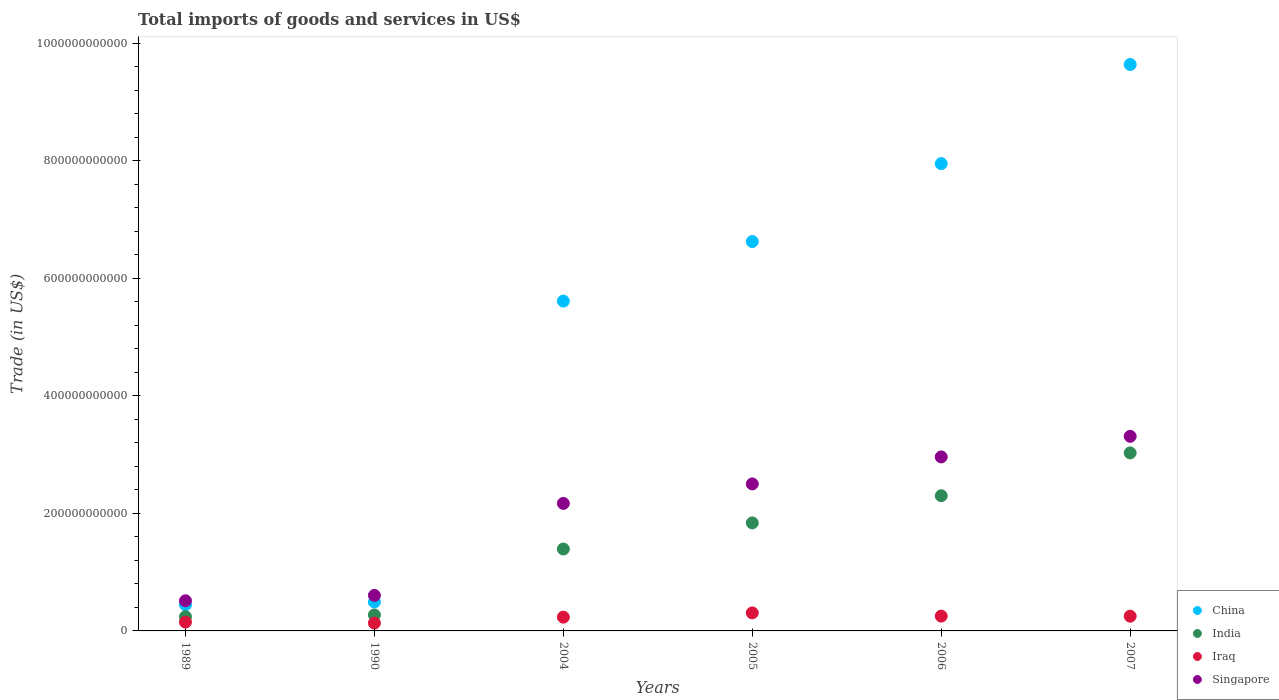How many different coloured dotlines are there?
Make the answer very short. 4. Is the number of dotlines equal to the number of legend labels?
Your answer should be very brief. Yes. What is the total imports of goods and services in Iraq in 1989?
Provide a succinct answer. 1.50e+1. Across all years, what is the maximum total imports of goods and services in Singapore?
Your answer should be very brief. 3.31e+11. Across all years, what is the minimum total imports of goods and services in Iraq?
Your answer should be very brief. 1.34e+1. In which year was the total imports of goods and services in China maximum?
Give a very brief answer. 2007. In which year was the total imports of goods and services in Singapore minimum?
Give a very brief answer. 1989. What is the total total imports of goods and services in Singapore in the graph?
Ensure brevity in your answer.  1.21e+12. What is the difference between the total imports of goods and services in India in 2004 and that in 2006?
Your answer should be very brief. -9.06e+1. What is the difference between the total imports of goods and services in Iraq in 2006 and the total imports of goods and services in Singapore in 1990?
Give a very brief answer. -3.53e+1. What is the average total imports of goods and services in Singapore per year?
Ensure brevity in your answer.  2.01e+11. In the year 2005, what is the difference between the total imports of goods and services in India and total imports of goods and services in China?
Your answer should be very brief. -4.79e+11. What is the ratio of the total imports of goods and services in Singapore in 1989 to that in 2005?
Give a very brief answer. 0.21. Is the total imports of goods and services in Singapore in 1990 less than that in 2006?
Make the answer very short. Yes. Is the difference between the total imports of goods and services in India in 1990 and 2005 greater than the difference between the total imports of goods and services in China in 1990 and 2005?
Give a very brief answer. Yes. What is the difference between the highest and the second highest total imports of goods and services in China?
Your answer should be compact. 1.69e+11. What is the difference between the highest and the lowest total imports of goods and services in China?
Your answer should be very brief. 9.19e+11. Does the total imports of goods and services in Iraq monotonically increase over the years?
Offer a very short reply. No. How many dotlines are there?
Your answer should be compact. 4. How many years are there in the graph?
Offer a very short reply. 6. What is the difference between two consecutive major ticks on the Y-axis?
Ensure brevity in your answer.  2.00e+11. Are the values on the major ticks of Y-axis written in scientific E-notation?
Make the answer very short. No. How many legend labels are there?
Offer a very short reply. 4. How are the legend labels stacked?
Give a very brief answer. Vertical. What is the title of the graph?
Make the answer very short. Total imports of goods and services in US$. What is the label or title of the Y-axis?
Your response must be concise. Trade (in US$). What is the Trade (in US$) in China in 1989?
Give a very brief answer. 4.45e+1. What is the Trade (in US$) in India in 1989?
Make the answer very short. 2.41e+1. What is the Trade (in US$) in Iraq in 1989?
Offer a terse response. 1.50e+1. What is the Trade (in US$) of Singapore in 1989?
Give a very brief answer. 5.13e+1. What is the Trade (in US$) of China in 1990?
Your answer should be compact. 4.92e+1. What is the Trade (in US$) of India in 1990?
Ensure brevity in your answer.  2.71e+1. What is the Trade (in US$) in Iraq in 1990?
Provide a succinct answer. 1.34e+1. What is the Trade (in US$) of Singapore in 1990?
Make the answer very short. 6.04e+1. What is the Trade (in US$) of China in 2004?
Make the answer very short. 5.61e+11. What is the Trade (in US$) in India in 2004?
Give a very brief answer. 1.39e+11. What is the Trade (in US$) in Iraq in 2004?
Make the answer very short. 2.34e+1. What is the Trade (in US$) in Singapore in 2004?
Give a very brief answer. 2.17e+11. What is the Trade (in US$) of China in 2005?
Give a very brief answer. 6.62e+11. What is the Trade (in US$) of India in 2005?
Your answer should be very brief. 1.84e+11. What is the Trade (in US$) of Iraq in 2005?
Offer a very short reply. 3.07e+1. What is the Trade (in US$) of Singapore in 2005?
Your answer should be compact. 2.50e+11. What is the Trade (in US$) in China in 2006?
Ensure brevity in your answer.  7.95e+11. What is the Trade (in US$) of India in 2006?
Your answer should be very brief. 2.30e+11. What is the Trade (in US$) in Iraq in 2006?
Provide a succinct answer. 2.52e+1. What is the Trade (in US$) in Singapore in 2006?
Your answer should be compact. 2.96e+11. What is the Trade (in US$) in China in 2007?
Ensure brevity in your answer.  9.63e+11. What is the Trade (in US$) of India in 2007?
Give a very brief answer. 3.03e+11. What is the Trade (in US$) of Iraq in 2007?
Your response must be concise. 2.50e+1. What is the Trade (in US$) of Singapore in 2007?
Your response must be concise. 3.31e+11. Across all years, what is the maximum Trade (in US$) of China?
Ensure brevity in your answer.  9.63e+11. Across all years, what is the maximum Trade (in US$) in India?
Provide a succinct answer. 3.03e+11. Across all years, what is the maximum Trade (in US$) of Iraq?
Ensure brevity in your answer.  3.07e+1. Across all years, what is the maximum Trade (in US$) in Singapore?
Provide a succinct answer. 3.31e+11. Across all years, what is the minimum Trade (in US$) of China?
Offer a very short reply. 4.45e+1. Across all years, what is the minimum Trade (in US$) in India?
Provide a short and direct response. 2.41e+1. Across all years, what is the minimum Trade (in US$) in Iraq?
Your response must be concise. 1.34e+1. Across all years, what is the minimum Trade (in US$) of Singapore?
Make the answer very short. 5.13e+1. What is the total Trade (in US$) of China in the graph?
Provide a short and direct response. 3.08e+12. What is the total Trade (in US$) of India in the graph?
Ensure brevity in your answer.  9.07e+11. What is the total Trade (in US$) of Iraq in the graph?
Provide a short and direct response. 1.33e+11. What is the total Trade (in US$) of Singapore in the graph?
Give a very brief answer. 1.21e+12. What is the difference between the Trade (in US$) of China in 1989 and that in 1990?
Keep it short and to the point. -4.69e+09. What is the difference between the Trade (in US$) of India in 1989 and that in 1990?
Provide a short and direct response. -3.00e+09. What is the difference between the Trade (in US$) in Iraq in 1989 and that in 1990?
Offer a terse response. 1.65e+09. What is the difference between the Trade (in US$) of Singapore in 1989 and that in 1990?
Your response must be concise. -9.15e+09. What is the difference between the Trade (in US$) of China in 1989 and that in 2004?
Give a very brief answer. -5.17e+11. What is the difference between the Trade (in US$) in India in 1989 and that in 2004?
Offer a very short reply. -1.15e+11. What is the difference between the Trade (in US$) of Iraq in 1989 and that in 2004?
Your response must be concise. -8.41e+09. What is the difference between the Trade (in US$) of Singapore in 1989 and that in 2004?
Provide a short and direct response. -1.66e+11. What is the difference between the Trade (in US$) of China in 1989 and that in 2005?
Your answer should be very brief. -6.18e+11. What is the difference between the Trade (in US$) of India in 1989 and that in 2005?
Give a very brief answer. -1.60e+11. What is the difference between the Trade (in US$) of Iraq in 1989 and that in 2005?
Provide a succinct answer. -1.57e+1. What is the difference between the Trade (in US$) in Singapore in 1989 and that in 2005?
Give a very brief answer. -1.99e+11. What is the difference between the Trade (in US$) in China in 1989 and that in 2006?
Offer a very short reply. -7.50e+11. What is the difference between the Trade (in US$) of India in 1989 and that in 2006?
Keep it short and to the point. -2.06e+11. What is the difference between the Trade (in US$) in Iraq in 1989 and that in 2006?
Offer a very short reply. -1.01e+1. What is the difference between the Trade (in US$) in Singapore in 1989 and that in 2006?
Your response must be concise. -2.45e+11. What is the difference between the Trade (in US$) in China in 1989 and that in 2007?
Ensure brevity in your answer.  -9.19e+11. What is the difference between the Trade (in US$) of India in 1989 and that in 2007?
Offer a terse response. -2.79e+11. What is the difference between the Trade (in US$) of Iraq in 1989 and that in 2007?
Your answer should be compact. -1.00e+1. What is the difference between the Trade (in US$) of Singapore in 1989 and that in 2007?
Your response must be concise. -2.80e+11. What is the difference between the Trade (in US$) of China in 1990 and that in 2004?
Provide a succinct answer. -5.12e+11. What is the difference between the Trade (in US$) in India in 1990 and that in 2004?
Keep it short and to the point. -1.12e+11. What is the difference between the Trade (in US$) of Iraq in 1990 and that in 2004?
Offer a very short reply. -1.01e+1. What is the difference between the Trade (in US$) in Singapore in 1990 and that in 2004?
Provide a short and direct response. -1.56e+11. What is the difference between the Trade (in US$) of China in 1990 and that in 2005?
Your answer should be very brief. -6.13e+11. What is the difference between the Trade (in US$) of India in 1990 and that in 2005?
Ensure brevity in your answer.  -1.57e+11. What is the difference between the Trade (in US$) of Iraq in 1990 and that in 2005?
Provide a short and direct response. -1.73e+1. What is the difference between the Trade (in US$) in Singapore in 1990 and that in 2005?
Ensure brevity in your answer.  -1.90e+11. What is the difference between the Trade (in US$) in China in 1990 and that in 2006?
Your response must be concise. -7.46e+11. What is the difference between the Trade (in US$) of India in 1990 and that in 2006?
Your response must be concise. -2.03e+11. What is the difference between the Trade (in US$) of Iraq in 1990 and that in 2006?
Your answer should be compact. -1.18e+1. What is the difference between the Trade (in US$) in Singapore in 1990 and that in 2006?
Ensure brevity in your answer.  -2.36e+11. What is the difference between the Trade (in US$) of China in 1990 and that in 2007?
Make the answer very short. -9.14e+11. What is the difference between the Trade (in US$) in India in 1990 and that in 2007?
Make the answer very short. -2.76e+11. What is the difference between the Trade (in US$) in Iraq in 1990 and that in 2007?
Make the answer very short. -1.17e+1. What is the difference between the Trade (in US$) in Singapore in 1990 and that in 2007?
Ensure brevity in your answer.  -2.71e+11. What is the difference between the Trade (in US$) of China in 2004 and that in 2005?
Offer a very short reply. -1.01e+11. What is the difference between the Trade (in US$) in India in 2004 and that in 2005?
Provide a short and direct response. -4.44e+1. What is the difference between the Trade (in US$) of Iraq in 2004 and that in 2005?
Keep it short and to the point. -7.24e+09. What is the difference between the Trade (in US$) in Singapore in 2004 and that in 2005?
Ensure brevity in your answer.  -3.32e+1. What is the difference between the Trade (in US$) in China in 2004 and that in 2006?
Offer a very short reply. -2.34e+11. What is the difference between the Trade (in US$) of India in 2004 and that in 2006?
Your answer should be very brief. -9.06e+1. What is the difference between the Trade (in US$) in Iraq in 2004 and that in 2006?
Your answer should be compact. -1.73e+09. What is the difference between the Trade (in US$) in Singapore in 2004 and that in 2006?
Make the answer very short. -7.91e+1. What is the difference between the Trade (in US$) of China in 2004 and that in 2007?
Your answer should be compact. -4.02e+11. What is the difference between the Trade (in US$) of India in 2004 and that in 2007?
Ensure brevity in your answer.  -1.63e+11. What is the difference between the Trade (in US$) of Iraq in 2004 and that in 2007?
Offer a terse response. -1.62e+09. What is the difference between the Trade (in US$) of Singapore in 2004 and that in 2007?
Provide a short and direct response. -1.14e+11. What is the difference between the Trade (in US$) of China in 2005 and that in 2006?
Offer a terse response. -1.33e+11. What is the difference between the Trade (in US$) of India in 2005 and that in 2006?
Your response must be concise. -4.62e+1. What is the difference between the Trade (in US$) in Iraq in 2005 and that in 2006?
Ensure brevity in your answer.  5.51e+09. What is the difference between the Trade (in US$) in Singapore in 2005 and that in 2006?
Ensure brevity in your answer.  -4.59e+1. What is the difference between the Trade (in US$) of China in 2005 and that in 2007?
Your response must be concise. -3.01e+11. What is the difference between the Trade (in US$) in India in 2005 and that in 2007?
Provide a succinct answer. -1.19e+11. What is the difference between the Trade (in US$) of Iraq in 2005 and that in 2007?
Provide a succinct answer. 5.62e+09. What is the difference between the Trade (in US$) in Singapore in 2005 and that in 2007?
Provide a short and direct response. -8.10e+1. What is the difference between the Trade (in US$) in China in 2006 and that in 2007?
Offer a terse response. -1.69e+11. What is the difference between the Trade (in US$) in India in 2006 and that in 2007?
Give a very brief answer. -7.28e+1. What is the difference between the Trade (in US$) of Iraq in 2006 and that in 2007?
Keep it short and to the point. 1.10e+08. What is the difference between the Trade (in US$) of Singapore in 2006 and that in 2007?
Provide a short and direct response. -3.50e+1. What is the difference between the Trade (in US$) of China in 1989 and the Trade (in US$) of India in 1990?
Your answer should be compact. 1.74e+1. What is the difference between the Trade (in US$) in China in 1989 and the Trade (in US$) in Iraq in 1990?
Ensure brevity in your answer.  3.12e+1. What is the difference between the Trade (in US$) in China in 1989 and the Trade (in US$) in Singapore in 1990?
Offer a terse response. -1.59e+1. What is the difference between the Trade (in US$) in India in 1989 and the Trade (in US$) in Iraq in 1990?
Keep it short and to the point. 1.08e+1. What is the difference between the Trade (in US$) of India in 1989 and the Trade (in US$) of Singapore in 1990?
Keep it short and to the point. -3.63e+1. What is the difference between the Trade (in US$) of Iraq in 1989 and the Trade (in US$) of Singapore in 1990?
Offer a very short reply. -4.54e+1. What is the difference between the Trade (in US$) in China in 1989 and the Trade (in US$) in India in 2004?
Offer a very short reply. -9.48e+1. What is the difference between the Trade (in US$) of China in 1989 and the Trade (in US$) of Iraq in 2004?
Give a very brief answer. 2.11e+1. What is the difference between the Trade (in US$) in China in 1989 and the Trade (in US$) in Singapore in 2004?
Ensure brevity in your answer.  -1.72e+11. What is the difference between the Trade (in US$) of India in 1989 and the Trade (in US$) of Iraq in 2004?
Provide a succinct answer. 7.05e+08. What is the difference between the Trade (in US$) in India in 1989 and the Trade (in US$) in Singapore in 2004?
Ensure brevity in your answer.  -1.93e+11. What is the difference between the Trade (in US$) in Iraq in 1989 and the Trade (in US$) in Singapore in 2004?
Give a very brief answer. -2.02e+11. What is the difference between the Trade (in US$) of China in 1989 and the Trade (in US$) of India in 2005?
Offer a terse response. -1.39e+11. What is the difference between the Trade (in US$) in China in 1989 and the Trade (in US$) in Iraq in 2005?
Your response must be concise. 1.39e+1. What is the difference between the Trade (in US$) in China in 1989 and the Trade (in US$) in Singapore in 2005?
Ensure brevity in your answer.  -2.06e+11. What is the difference between the Trade (in US$) of India in 1989 and the Trade (in US$) of Iraq in 2005?
Provide a short and direct response. -6.54e+09. What is the difference between the Trade (in US$) of India in 1989 and the Trade (in US$) of Singapore in 2005?
Keep it short and to the point. -2.26e+11. What is the difference between the Trade (in US$) in Iraq in 1989 and the Trade (in US$) in Singapore in 2005?
Offer a terse response. -2.35e+11. What is the difference between the Trade (in US$) in China in 1989 and the Trade (in US$) in India in 2006?
Provide a short and direct response. -1.85e+11. What is the difference between the Trade (in US$) in China in 1989 and the Trade (in US$) in Iraq in 2006?
Your response must be concise. 1.94e+1. What is the difference between the Trade (in US$) of China in 1989 and the Trade (in US$) of Singapore in 2006?
Provide a succinct answer. -2.51e+11. What is the difference between the Trade (in US$) in India in 1989 and the Trade (in US$) in Iraq in 2006?
Keep it short and to the point. -1.02e+09. What is the difference between the Trade (in US$) of India in 1989 and the Trade (in US$) of Singapore in 2006?
Give a very brief answer. -2.72e+11. What is the difference between the Trade (in US$) in Iraq in 1989 and the Trade (in US$) in Singapore in 2006?
Provide a succinct answer. -2.81e+11. What is the difference between the Trade (in US$) of China in 1989 and the Trade (in US$) of India in 2007?
Provide a succinct answer. -2.58e+11. What is the difference between the Trade (in US$) of China in 1989 and the Trade (in US$) of Iraq in 2007?
Provide a succinct answer. 1.95e+1. What is the difference between the Trade (in US$) in China in 1989 and the Trade (in US$) in Singapore in 2007?
Your response must be concise. -2.86e+11. What is the difference between the Trade (in US$) of India in 1989 and the Trade (in US$) of Iraq in 2007?
Ensure brevity in your answer.  -9.13e+08. What is the difference between the Trade (in US$) in India in 1989 and the Trade (in US$) in Singapore in 2007?
Your answer should be compact. -3.07e+11. What is the difference between the Trade (in US$) of Iraq in 1989 and the Trade (in US$) of Singapore in 2007?
Offer a very short reply. -3.16e+11. What is the difference between the Trade (in US$) in China in 1990 and the Trade (in US$) in India in 2004?
Your response must be concise. -9.01e+1. What is the difference between the Trade (in US$) in China in 1990 and the Trade (in US$) in Iraq in 2004?
Your response must be concise. 2.58e+1. What is the difference between the Trade (in US$) in China in 1990 and the Trade (in US$) in Singapore in 2004?
Give a very brief answer. -1.68e+11. What is the difference between the Trade (in US$) of India in 1990 and the Trade (in US$) of Iraq in 2004?
Provide a succinct answer. 3.70e+09. What is the difference between the Trade (in US$) in India in 1990 and the Trade (in US$) in Singapore in 2004?
Provide a succinct answer. -1.90e+11. What is the difference between the Trade (in US$) of Iraq in 1990 and the Trade (in US$) of Singapore in 2004?
Your answer should be very brief. -2.04e+11. What is the difference between the Trade (in US$) in China in 1990 and the Trade (in US$) in India in 2005?
Offer a very short reply. -1.35e+11. What is the difference between the Trade (in US$) of China in 1990 and the Trade (in US$) of Iraq in 2005?
Your answer should be compact. 1.86e+1. What is the difference between the Trade (in US$) of China in 1990 and the Trade (in US$) of Singapore in 2005?
Give a very brief answer. -2.01e+11. What is the difference between the Trade (in US$) in India in 1990 and the Trade (in US$) in Iraq in 2005?
Offer a very short reply. -3.54e+09. What is the difference between the Trade (in US$) of India in 1990 and the Trade (in US$) of Singapore in 2005?
Make the answer very short. -2.23e+11. What is the difference between the Trade (in US$) in Iraq in 1990 and the Trade (in US$) in Singapore in 2005?
Provide a short and direct response. -2.37e+11. What is the difference between the Trade (in US$) in China in 1990 and the Trade (in US$) in India in 2006?
Offer a very short reply. -1.81e+11. What is the difference between the Trade (in US$) of China in 1990 and the Trade (in US$) of Iraq in 2006?
Provide a short and direct response. 2.41e+1. What is the difference between the Trade (in US$) of China in 1990 and the Trade (in US$) of Singapore in 2006?
Keep it short and to the point. -2.47e+11. What is the difference between the Trade (in US$) in India in 1990 and the Trade (in US$) in Iraq in 2006?
Ensure brevity in your answer.  1.98e+09. What is the difference between the Trade (in US$) of India in 1990 and the Trade (in US$) of Singapore in 2006?
Provide a short and direct response. -2.69e+11. What is the difference between the Trade (in US$) in Iraq in 1990 and the Trade (in US$) in Singapore in 2006?
Provide a short and direct response. -2.83e+11. What is the difference between the Trade (in US$) in China in 1990 and the Trade (in US$) in India in 2007?
Make the answer very short. -2.54e+11. What is the difference between the Trade (in US$) in China in 1990 and the Trade (in US$) in Iraq in 2007?
Offer a very short reply. 2.42e+1. What is the difference between the Trade (in US$) in China in 1990 and the Trade (in US$) in Singapore in 2007?
Give a very brief answer. -2.82e+11. What is the difference between the Trade (in US$) in India in 1990 and the Trade (in US$) in Iraq in 2007?
Offer a terse response. 2.09e+09. What is the difference between the Trade (in US$) of India in 1990 and the Trade (in US$) of Singapore in 2007?
Offer a very short reply. -3.04e+11. What is the difference between the Trade (in US$) of Iraq in 1990 and the Trade (in US$) of Singapore in 2007?
Your response must be concise. -3.18e+11. What is the difference between the Trade (in US$) in China in 2004 and the Trade (in US$) in India in 2005?
Provide a short and direct response. 3.77e+11. What is the difference between the Trade (in US$) in China in 2004 and the Trade (in US$) in Iraq in 2005?
Offer a terse response. 5.30e+11. What is the difference between the Trade (in US$) in China in 2004 and the Trade (in US$) in Singapore in 2005?
Provide a short and direct response. 3.11e+11. What is the difference between the Trade (in US$) of India in 2004 and the Trade (in US$) of Iraq in 2005?
Your answer should be very brief. 1.09e+11. What is the difference between the Trade (in US$) of India in 2004 and the Trade (in US$) of Singapore in 2005?
Ensure brevity in your answer.  -1.11e+11. What is the difference between the Trade (in US$) of Iraq in 2004 and the Trade (in US$) of Singapore in 2005?
Offer a terse response. -2.27e+11. What is the difference between the Trade (in US$) in China in 2004 and the Trade (in US$) in India in 2006?
Keep it short and to the point. 3.31e+11. What is the difference between the Trade (in US$) of China in 2004 and the Trade (in US$) of Iraq in 2006?
Your answer should be very brief. 5.36e+11. What is the difference between the Trade (in US$) of China in 2004 and the Trade (in US$) of Singapore in 2006?
Give a very brief answer. 2.65e+11. What is the difference between the Trade (in US$) of India in 2004 and the Trade (in US$) of Iraq in 2006?
Offer a very short reply. 1.14e+11. What is the difference between the Trade (in US$) in India in 2004 and the Trade (in US$) in Singapore in 2006?
Keep it short and to the point. -1.57e+11. What is the difference between the Trade (in US$) in Iraq in 2004 and the Trade (in US$) in Singapore in 2006?
Provide a succinct answer. -2.73e+11. What is the difference between the Trade (in US$) in China in 2004 and the Trade (in US$) in India in 2007?
Keep it short and to the point. 2.58e+11. What is the difference between the Trade (in US$) in China in 2004 and the Trade (in US$) in Iraq in 2007?
Your answer should be very brief. 5.36e+11. What is the difference between the Trade (in US$) of China in 2004 and the Trade (in US$) of Singapore in 2007?
Your answer should be very brief. 2.30e+11. What is the difference between the Trade (in US$) of India in 2004 and the Trade (in US$) of Iraq in 2007?
Your response must be concise. 1.14e+11. What is the difference between the Trade (in US$) of India in 2004 and the Trade (in US$) of Singapore in 2007?
Ensure brevity in your answer.  -1.92e+11. What is the difference between the Trade (in US$) in Iraq in 2004 and the Trade (in US$) in Singapore in 2007?
Keep it short and to the point. -3.08e+11. What is the difference between the Trade (in US$) in China in 2005 and the Trade (in US$) in India in 2006?
Offer a terse response. 4.32e+11. What is the difference between the Trade (in US$) of China in 2005 and the Trade (in US$) of Iraq in 2006?
Your response must be concise. 6.37e+11. What is the difference between the Trade (in US$) in China in 2005 and the Trade (in US$) in Singapore in 2006?
Provide a succinct answer. 3.66e+11. What is the difference between the Trade (in US$) in India in 2005 and the Trade (in US$) in Iraq in 2006?
Offer a terse response. 1.59e+11. What is the difference between the Trade (in US$) in India in 2005 and the Trade (in US$) in Singapore in 2006?
Keep it short and to the point. -1.12e+11. What is the difference between the Trade (in US$) of Iraq in 2005 and the Trade (in US$) of Singapore in 2006?
Offer a very short reply. -2.65e+11. What is the difference between the Trade (in US$) in China in 2005 and the Trade (in US$) in India in 2007?
Give a very brief answer. 3.60e+11. What is the difference between the Trade (in US$) of China in 2005 and the Trade (in US$) of Iraq in 2007?
Ensure brevity in your answer.  6.37e+11. What is the difference between the Trade (in US$) in China in 2005 and the Trade (in US$) in Singapore in 2007?
Provide a succinct answer. 3.31e+11. What is the difference between the Trade (in US$) of India in 2005 and the Trade (in US$) of Iraq in 2007?
Your answer should be compact. 1.59e+11. What is the difference between the Trade (in US$) of India in 2005 and the Trade (in US$) of Singapore in 2007?
Your answer should be very brief. -1.47e+11. What is the difference between the Trade (in US$) in Iraq in 2005 and the Trade (in US$) in Singapore in 2007?
Make the answer very short. -3.00e+11. What is the difference between the Trade (in US$) in China in 2006 and the Trade (in US$) in India in 2007?
Offer a very short reply. 4.92e+11. What is the difference between the Trade (in US$) of China in 2006 and the Trade (in US$) of Iraq in 2007?
Provide a short and direct response. 7.70e+11. What is the difference between the Trade (in US$) of China in 2006 and the Trade (in US$) of Singapore in 2007?
Give a very brief answer. 4.64e+11. What is the difference between the Trade (in US$) of India in 2006 and the Trade (in US$) of Iraq in 2007?
Provide a short and direct response. 2.05e+11. What is the difference between the Trade (in US$) of India in 2006 and the Trade (in US$) of Singapore in 2007?
Your response must be concise. -1.01e+11. What is the difference between the Trade (in US$) of Iraq in 2006 and the Trade (in US$) of Singapore in 2007?
Your answer should be very brief. -3.06e+11. What is the average Trade (in US$) in China per year?
Ensure brevity in your answer.  5.13e+11. What is the average Trade (in US$) in India per year?
Provide a succinct answer. 1.51e+11. What is the average Trade (in US$) in Iraq per year?
Your answer should be compact. 2.21e+1. What is the average Trade (in US$) in Singapore per year?
Your answer should be compact. 2.01e+11. In the year 1989, what is the difference between the Trade (in US$) in China and Trade (in US$) in India?
Your response must be concise. 2.04e+1. In the year 1989, what is the difference between the Trade (in US$) in China and Trade (in US$) in Iraq?
Keep it short and to the point. 2.95e+1. In the year 1989, what is the difference between the Trade (in US$) in China and Trade (in US$) in Singapore?
Give a very brief answer. -6.73e+09. In the year 1989, what is the difference between the Trade (in US$) of India and Trade (in US$) of Iraq?
Ensure brevity in your answer.  9.12e+09. In the year 1989, what is the difference between the Trade (in US$) in India and Trade (in US$) in Singapore?
Make the answer very short. -2.71e+1. In the year 1989, what is the difference between the Trade (in US$) in Iraq and Trade (in US$) in Singapore?
Make the answer very short. -3.63e+1. In the year 1990, what is the difference between the Trade (in US$) in China and Trade (in US$) in India?
Give a very brief answer. 2.21e+1. In the year 1990, what is the difference between the Trade (in US$) in China and Trade (in US$) in Iraq?
Ensure brevity in your answer.  3.59e+1. In the year 1990, what is the difference between the Trade (in US$) in China and Trade (in US$) in Singapore?
Give a very brief answer. -1.12e+1. In the year 1990, what is the difference between the Trade (in US$) of India and Trade (in US$) of Iraq?
Provide a succinct answer. 1.38e+1. In the year 1990, what is the difference between the Trade (in US$) of India and Trade (in US$) of Singapore?
Keep it short and to the point. -3.33e+1. In the year 1990, what is the difference between the Trade (in US$) in Iraq and Trade (in US$) in Singapore?
Make the answer very short. -4.70e+1. In the year 2004, what is the difference between the Trade (in US$) in China and Trade (in US$) in India?
Ensure brevity in your answer.  4.22e+11. In the year 2004, what is the difference between the Trade (in US$) of China and Trade (in US$) of Iraq?
Ensure brevity in your answer.  5.38e+11. In the year 2004, what is the difference between the Trade (in US$) in China and Trade (in US$) in Singapore?
Keep it short and to the point. 3.44e+11. In the year 2004, what is the difference between the Trade (in US$) of India and Trade (in US$) of Iraq?
Keep it short and to the point. 1.16e+11. In the year 2004, what is the difference between the Trade (in US$) of India and Trade (in US$) of Singapore?
Provide a succinct answer. -7.76e+1. In the year 2004, what is the difference between the Trade (in US$) of Iraq and Trade (in US$) of Singapore?
Provide a short and direct response. -1.93e+11. In the year 2005, what is the difference between the Trade (in US$) in China and Trade (in US$) in India?
Provide a short and direct response. 4.79e+11. In the year 2005, what is the difference between the Trade (in US$) in China and Trade (in US$) in Iraq?
Provide a succinct answer. 6.32e+11. In the year 2005, what is the difference between the Trade (in US$) of China and Trade (in US$) of Singapore?
Your response must be concise. 4.12e+11. In the year 2005, what is the difference between the Trade (in US$) of India and Trade (in US$) of Iraq?
Your answer should be compact. 1.53e+11. In the year 2005, what is the difference between the Trade (in US$) of India and Trade (in US$) of Singapore?
Your answer should be very brief. -6.63e+1. In the year 2005, what is the difference between the Trade (in US$) of Iraq and Trade (in US$) of Singapore?
Offer a very short reply. -2.19e+11. In the year 2006, what is the difference between the Trade (in US$) of China and Trade (in US$) of India?
Make the answer very short. 5.65e+11. In the year 2006, what is the difference between the Trade (in US$) in China and Trade (in US$) in Iraq?
Your answer should be compact. 7.70e+11. In the year 2006, what is the difference between the Trade (in US$) in China and Trade (in US$) in Singapore?
Make the answer very short. 4.99e+11. In the year 2006, what is the difference between the Trade (in US$) of India and Trade (in US$) of Iraq?
Keep it short and to the point. 2.05e+11. In the year 2006, what is the difference between the Trade (in US$) in India and Trade (in US$) in Singapore?
Offer a terse response. -6.60e+1. In the year 2006, what is the difference between the Trade (in US$) of Iraq and Trade (in US$) of Singapore?
Your answer should be compact. -2.71e+11. In the year 2007, what is the difference between the Trade (in US$) in China and Trade (in US$) in India?
Offer a very short reply. 6.61e+11. In the year 2007, what is the difference between the Trade (in US$) of China and Trade (in US$) of Iraq?
Give a very brief answer. 9.38e+11. In the year 2007, what is the difference between the Trade (in US$) in China and Trade (in US$) in Singapore?
Ensure brevity in your answer.  6.32e+11. In the year 2007, what is the difference between the Trade (in US$) of India and Trade (in US$) of Iraq?
Ensure brevity in your answer.  2.78e+11. In the year 2007, what is the difference between the Trade (in US$) of India and Trade (in US$) of Singapore?
Your answer should be very brief. -2.82e+1. In the year 2007, what is the difference between the Trade (in US$) of Iraq and Trade (in US$) of Singapore?
Ensure brevity in your answer.  -3.06e+11. What is the ratio of the Trade (in US$) in China in 1989 to that in 1990?
Your response must be concise. 0.9. What is the ratio of the Trade (in US$) in India in 1989 to that in 1990?
Offer a terse response. 0.89. What is the ratio of the Trade (in US$) of Iraq in 1989 to that in 1990?
Offer a very short reply. 1.12. What is the ratio of the Trade (in US$) in Singapore in 1989 to that in 1990?
Offer a very short reply. 0.85. What is the ratio of the Trade (in US$) in China in 1989 to that in 2004?
Your answer should be very brief. 0.08. What is the ratio of the Trade (in US$) of India in 1989 to that in 2004?
Make the answer very short. 0.17. What is the ratio of the Trade (in US$) of Iraq in 1989 to that in 2004?
Offer a very short reply. 0.64. What is the ratio of the Trade (in US$) of Singapore in 1989 to that in 2004?
Your answer should be compact. 0.24. What is the ratio of the Trade (in US$) of China in 1989 to that in 2005?
Make the answer very short. 0.07. What is the ratio of the Trade (in US$) in India in 1989 to that in 2005?
Keep it short and to the point. 0.13. What is the ratio of the Trade (in US$) of Iraq in 1989 to that in 2005?
Your response must be concise. 0.49. What is the ratio of the Trade (in US$) in Singapore in 1989 to that in 2005?
Provide a short and direct response. 0.2. What is the ratio of the Trade (in US$) in China in 1989 to that in 2006?
Give a very brief answer. 0.06. What is the ratio of the Trade (in US$) of India in 1989 to that in 2006?
Your answer should be compact. 0.1. What is the ratio of the Trade (in US$) of Iraq in 1989 to that in 2006?
Offer a very short reply. 0.6. What is the ratio of the Trade (in US$) in Singapore in 1989 to that in 2006?
Offer a very short reply. 0.17. What is the ratio of the Trade (in US$) of China in 1989 to that in 2007?
Ensure brevity in your answer.  0.05. What is the ratio of the Trade (in US$) in India in 1989 to that in 2007?
Your answer should be very brief. 0.08. What is the ratio of the Trade (in US$) in Iraq in 1989 to that in 2007?
Your answer should be compact. 0.6. What is the ratio of the Trade (in US$) in Singapore in 1989 to that in 2007?
Your answer should be compact. 0.15. What is the ratio of the Trade (in US$) of China in 1990 to that in 2004?
Give a very brief answer. 0.09. What is the ratio of the Trade (in US$) in India in 1990 to that in 2004?
Keep it short and to the point. 0.19. What is the ratio of the Trade (in US$) in Iraq in 1990 to that in 2004?
Keep it short and to the point. 0.57. What is the ratio of the Trade (in US$) in Singapore in 1990 to that in 2004?
Provide a short and direct response. 0.28. What is the ratio of the Trade (in US$) in China in 1990 to that in 2005?
Provide a short and direct response. 0.07. What is the ratio of the Trade (in US$) in India in 1990 to that in 2005?
Ensure brevity in your answer.  0.15. What is the ratio of the Trade (in US$) in Iraq in 1990 to that in 2005?
Keep it short and to the point. 0.44. What is the ratio of the Trade (in US$) of Singapore in 1990 to that in 2005?
Your answer should be very brief. 0.24. What is the ratio of the Trade (in US$) in China in 1990 to that in 2006?
Offer a terse response. 0.06. What is the ratio of the Trade (in US$) of India in 1990 to that in 2006?
Provide a succinct answer. 0.12. What is the ratio of the Trade (in US$) in Iraq in 1990 to that in 2006?
Offer a very short reply. 0.53. What is the ratio of the Trade (in US$) of Singapore in 1990 to that in 2006?
Your response must be concise. 0.2. What is the ratio of the Trade (in US$) of China in 1990 to that in 2007?
Ensure brevity in your answer.  0.05. What is the ratio of the Trade (in US$) of India in 1990 to that in 2007?
Your response must be concise. 0.09. What is the ratio of the Trade (in US$) in Iraq in 1990 to that in 2007?
Give a very brief answer. 0.53. What is the ratio of the Trade (in US$) in Singapore in 1990 to that in 2007?
Provide a succinct answer. 0.18. What is the ratio of the Trade (in US$) of China in 2004 to that in 2005?
Make the answer very short. 0.85. What is the ratio of the Trade (in US$) in India in 2004 to that in 2005?
Make the answer very short. 0.76. What is the ratio of the Trade (in US$) in Iraq in 2004 to that in 2005?
Keep it short and to the point. 0.76. What is the ratio of the Trade (in US$) in Singapore in 2004 to that in 2005?
Give a very brief answer. 0.87. What is the ratio of the Trade (in US$) of China in 2004 to that in 2006?
Offer a terse response. 0.71. What is the ratio of the Trade (in US$) of India in 2004 to that in 2006?
Provide a short and direct response. 0.61. What is the ratio of the Trade (in US$) of Iraq in 2004 to that in 2006?
Offer a very short reply. 0.93. What is the ratio of the Trade (in US$) in Singapore in 2004 to that in 2006?
Provide a short and direct response. 0.73. What is the ratio of the Trade (in US$) in China in 2004 to that in 2007?
Provide a short and direct response. 0.58. What is the ratio of the Trade (in US$) of India in 2004 to that in 2007?
Keep it short and to the point. 0.46. What is the ratio of the Trade (in US$) in Iraq in 2004 to that in 2007?
Offer a very short reply. 0.94. What is the ratio of the Trade (in US$) in Singapore in 2004 to that in 2007?
Give a very brief answer. 0.66. What is the ratio of the Trade (in US$) of India in 2005 to that in 2006?
Give a very brief answer. 0.8. What is the ratio of the Trade (in US$) of Iraq in 2005 to that in 2006?
Your answer should be very brief. 1.22. What is the ratio of the Trade (in US$) in Singapore in 2005 to that in 2006?
Offer a very short reply. 0.84. What is the ratio of the Trade (in US$) in China in 2005 to that in 2007?
Keep it short and to the point. 0.69. What is the ratio of the Trade (in US$) of India in 2005 to that in 2007?
Your response must be concise. 0.61. What is the ratio of the Trade (in US$) in Iraq in 2005 to that in 2007?
Ensure brevity in your answer.  1.22. What is the ratio of the Trade (in US$) in Singapore in 2005 to that in 2007?
Provide a succinct answer. 0.76. What is the ratio of the Trade (in US$) of China in 2006 to that in 2007?
Ensure brevity in your answer.  0.82. What is the ratio of the Trade (in US$) in India in 2006 to that in 2007?
Provide a short and direct response. 0.76. What is the ratio of the Trade (in US$) in Iraq in 2006 to that in 2007?
Provide a succinct answer. 1. What is the ratio of the Trade (in US$) of Singapore in 2006 to that in 2007?
Make the answer very short. 0.89. What is the difference between the highest and the second highest Trade (in US$) of China?
Make the answer very short. 1.69e+11. What is the difference between the highest and the second highest Trade (in US$) in India?
Provide a succinct answer. 7.28e+1. What is the difference between the highest and the second highest Trade (in US$) in Iraq?
Ensure brevity in your answer.  5.51e+09. What is the difference between the highest and the second highest Trade (in US$) of Singapore?
Your answer should be very brief. 3.50e+1. What is the difference between the highest and the lowest Trade (in US$) in China?
Your response must be concise. 9.19e+11. What is the difference between the highest and the lowest Trade (in US$) in India?
Make the answer very short. 2.79e+11. What is the difference between the highest and the lowest Trade (in US$) of Iraq?
Your response must be concise. 1.73e+1. What is the difference between the highest and the lowest Trade (in US$) in Singapore?
Offer a terse response. 2.80e+11. 